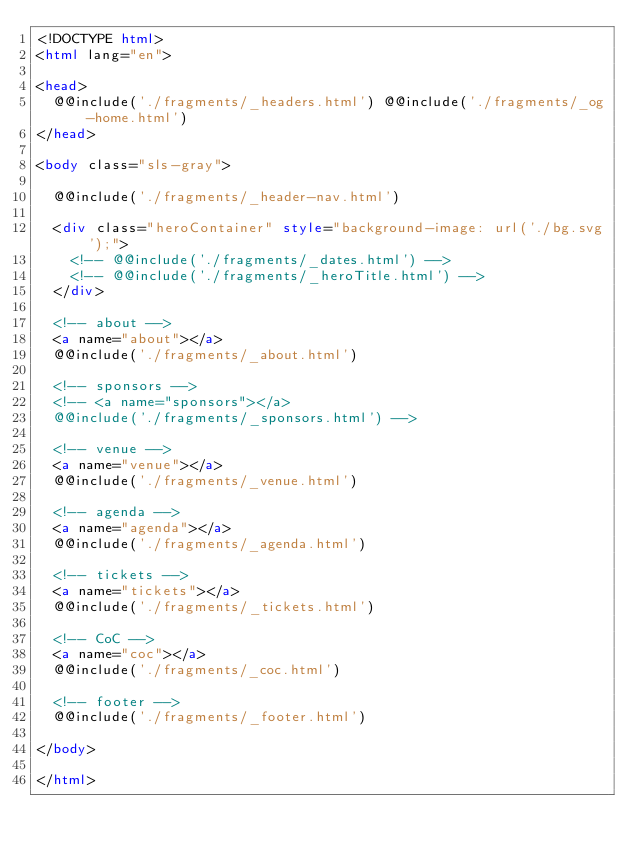Convert code to text. <code><loc_0><loc_0><loc_500><loc_500><_HTML_><!DOCTYPE html>
<html lang="en">

<head>
  @@include('./fragments/_headers.html') @@include('./fragments/_og-home.html')
</head>

<body class="sls-gray">

  @@include('./fragments/_header-nav.html')

  <div class="heroContainer" style="background-image: url('./bg.svg');">
    <!-- @@include('./fragments/_dates.html') -->
    <!-- @@include('./fragments/_heroTitle.html') -->
  </div>

  <!-- about -->
  <a name="about"></a>
  @@include('./fragments/_about.html')

  <!-- sponsors -->
  <!-- <a name="sponsors"></a>
  @@include('./fragments/_sponsors.html') -->

  <!-- venue -->
  <a name="venue"></a>
  @@include('./fragments/_venue.html')

  <!-- agenda -->
  <a name="agenda"></a>
  @@include('./fragments/_agenda.html')

  <!-- tickets -->
  <a name="tickets"></a>
  @@include('./fragments/_tickets.html')

  <!-- CoC -->
  <a name="coc"></a>
  @@include('./fragments/_coc.html')

  <!-- footer -->
  @@include('./fragments/_footer.html')

</body>

</html></code> 